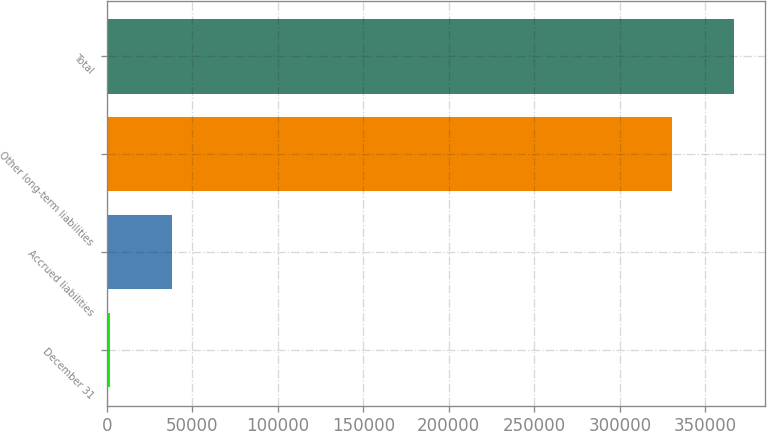Convert chart to OTSL. <chart><loc_0><loc_0><loc_500><loc_500><bar_chart><fcel>December 31<fcel>Accrued liabilities<fcel>Other long-term liabilities<fcel>Total<nl><fcel>2007<fcel>38097.9<fcel>330708<fcel>366799<nl></chart> 